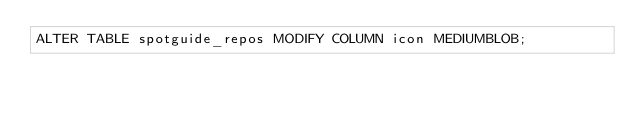Convert code to text. <code><loc_0><loc_0><loc_500><loc_500><_SQL_>ALTER TABLE spotguide_repos MODIFY COLUMN icon MEDIUMBLOB;</code> 